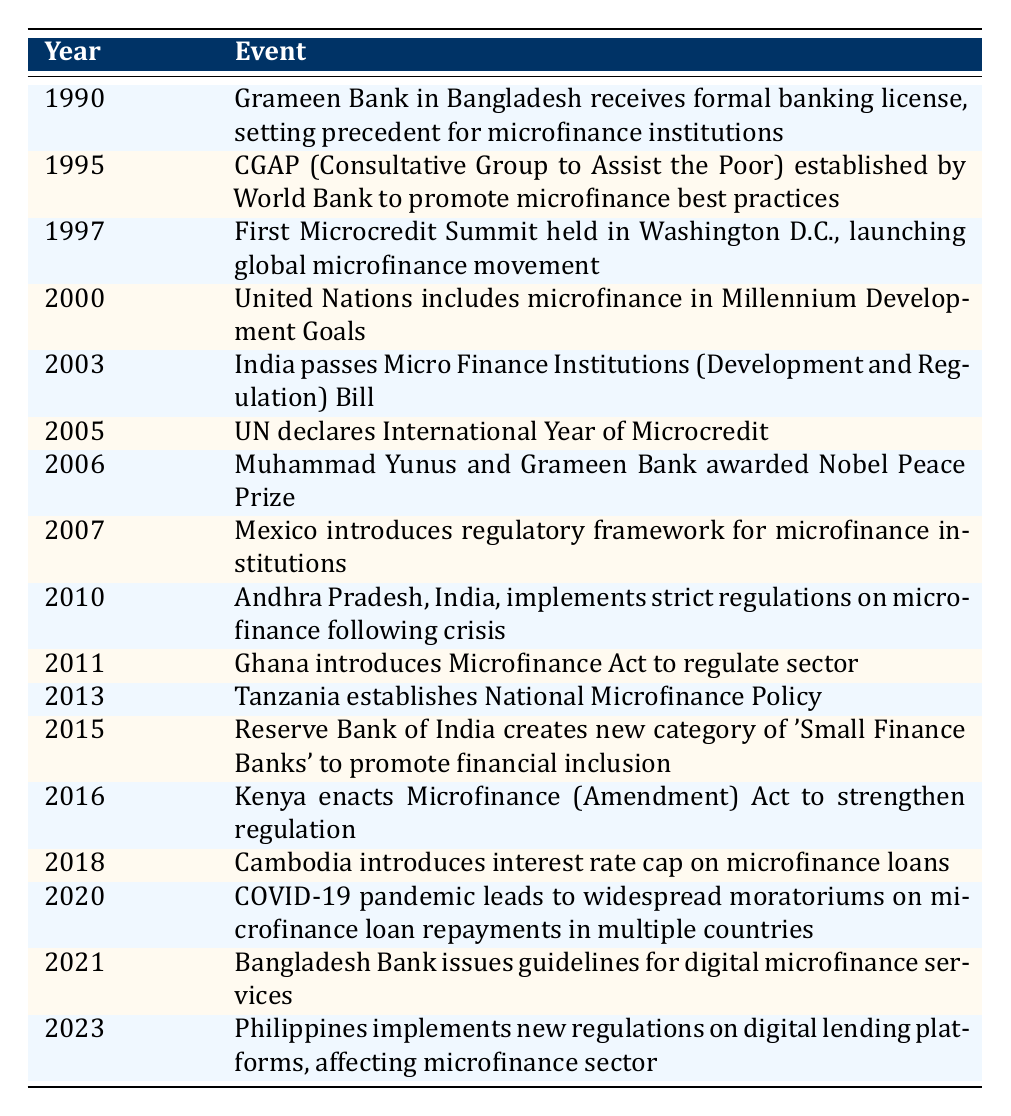What significant event occurred in 1990 related to microfinance? The table indicates that in 1990, the Grameen Bank in Bangladesh received a formal banking license, which set a precedent for microfinance institutions.
Answer: Grameen Bank receives formal banking license In which year did the United Nations include microfinance in its Millennium Development Goals? According to the table, the United Nations included microfinance in the Millennium Development Goals in the year 2000.
Answer: 2000 True or False: The first Microcredit Summit was held in 2000. The table shows that the first Microcredit Summit occurred in 1997, making the statement false.
Answer: False What was the regulatory action taken by India in 2003 regarding microfinance? The table states that in 2003, India passed the Micro Finance Institutions (Development and Regulation) Bill, clearly indicating a regulatory action.
Answer: India passed Micro Finance Institutions Bill How many years passed between the establishment of the CGAP and the International Year of Microcredit? The CGAP was established in 1995 and the International Year of Microcredit was declared in 2005, which is a span of 10 years. Calculation: 2005 - 1995 = 10.
Answer: 10 years Which two events directly relate to laws passed or regulations established in developing countries in the early 2010s? From the table, the relevant events are that in 2010, Andhra Pradesh, India, implemented strict regulations on microfinance, and in 2011, Ghana introduced the Microfinance Act to regulate the sector.
Answer: India in 2010 and Ghana in 2011 What was the impact of the COVID-19 pandemic on microfinance loans in 2020? In 2020, the table notes that the COVID-19 pandemic led to widespread moratoriums on microfinance loan repayments in multiple countries, indicating significant financial impacts.
Answer: Widespread moratoriums on repayments What major change in microfinance regulations occurred in the Philippines in 2023? The table shows that in 2023, the Philippines implemented new regulations on digital lending platforms, which directly affects the microfinance sector.
Answer: New regulations on digital lending platforms List all the events that occurred in the 2000s related to microfinance. Referencing the table, the events are: 2000 - United Nations includes microfinance in Millennium Development Goals, 2003 - India passes Micro Finance Institutions Bill, 2005 - UN declares International Year of Microcredit, 2006 - Muhammad Yunus and Grameen Bank awarded Nobel Peace Prize, 2007 - Mexico introduces regulatory framework for microfinance institutions.
Answer: Multiple events in 2000s 